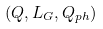Convert formula to latex. <formula><loc_0><loc_0><loc_500><loc_500>( Q , L _ { G } , Q _ { p h } )</formula> 